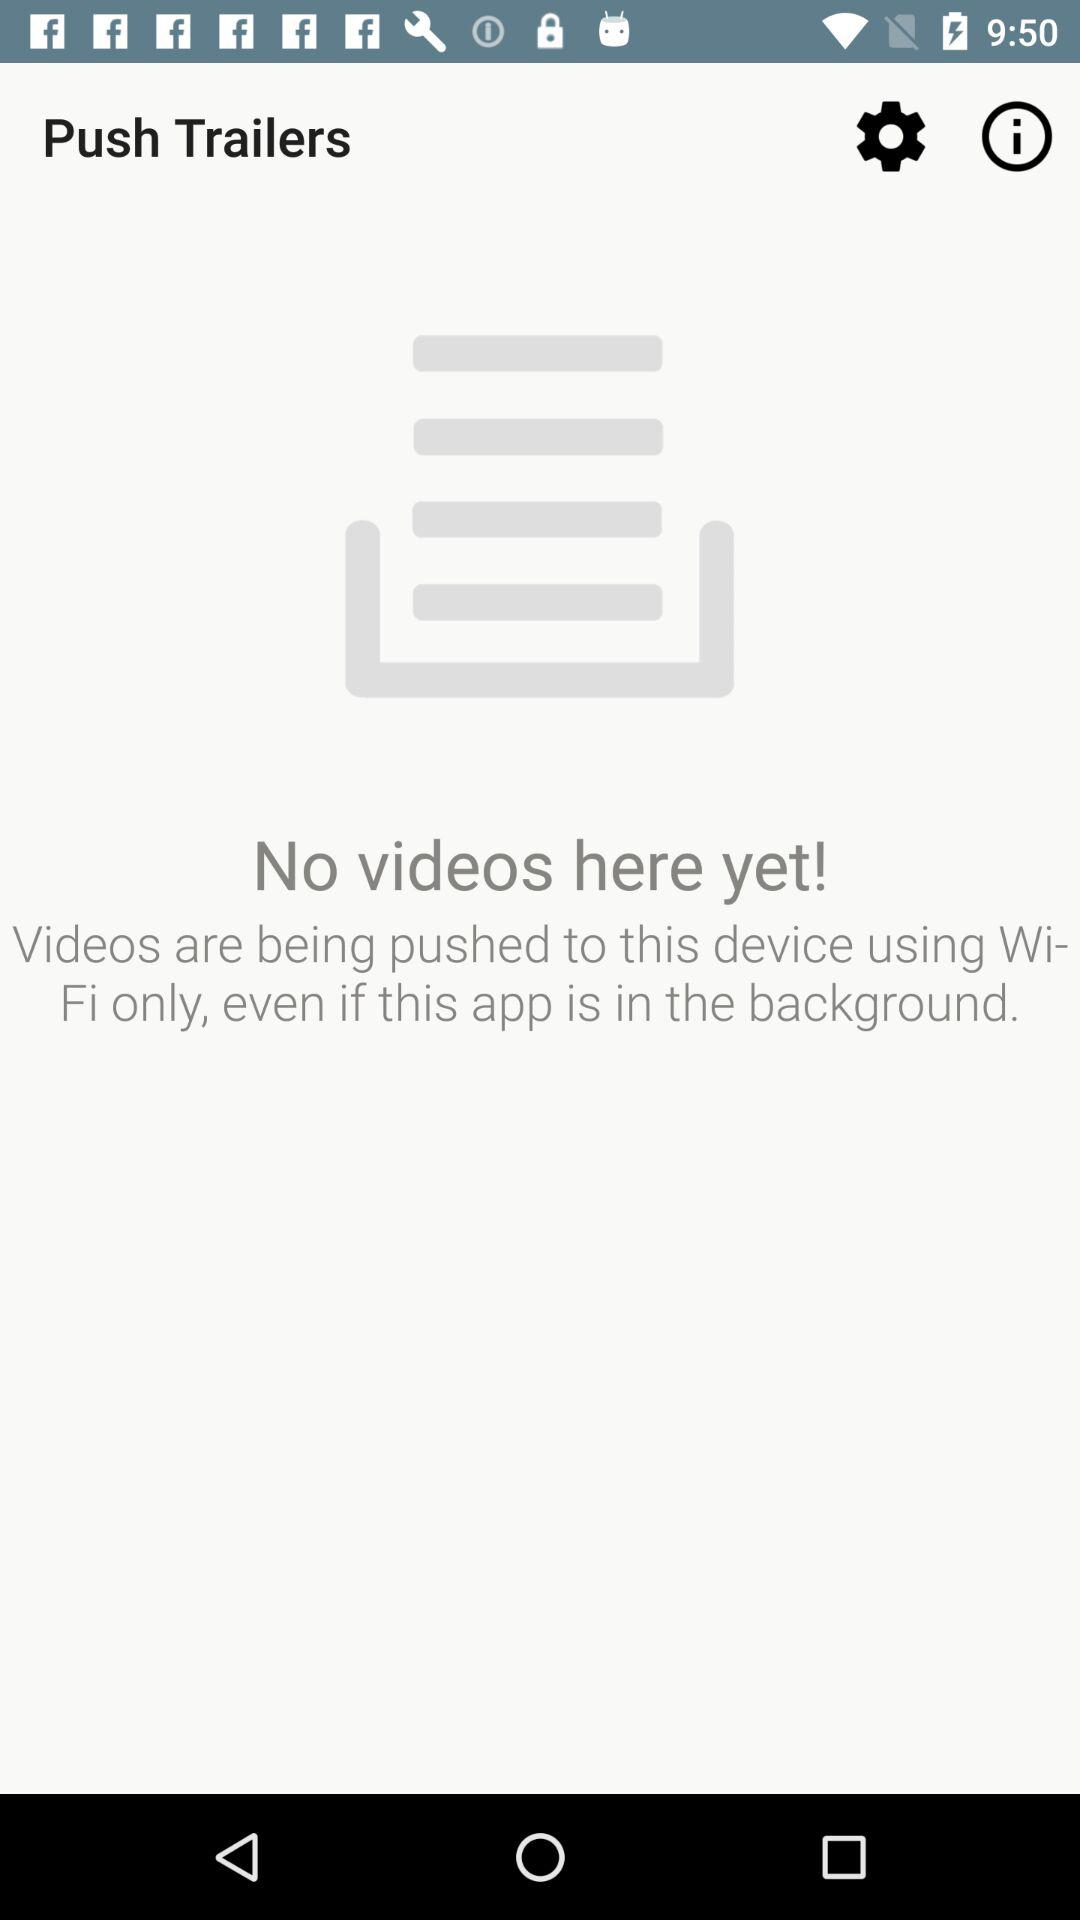What is the application name? The application name is "Push Trailers". 